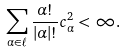Convert formula to latex. <formula><loc_0><loc_0><loc_500><loc_500>\sum _ { \alpha \in \ell } \frac { \alpha ! } { | \alpha | ! } c _ { \alpha } ^ { 2 } < \infty .</formula> 